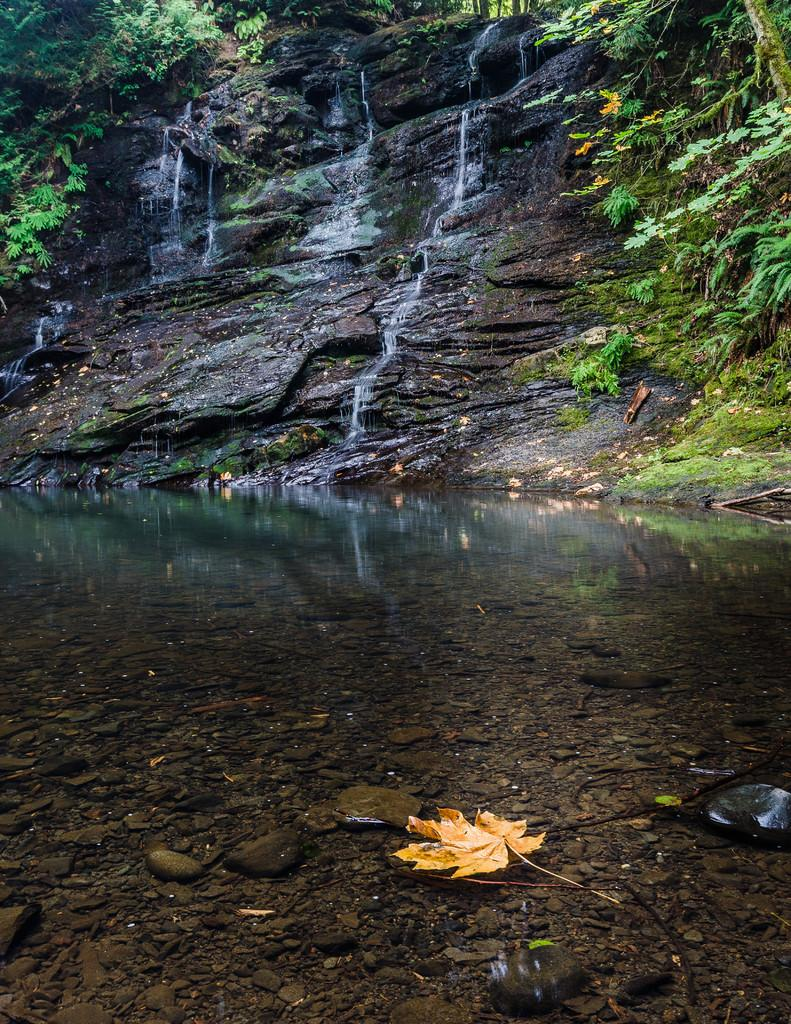What type of natural environment is depicted in the image? The image shows a forest with water. What geographical feature can be seen in the image? There is a rocky hill in the image. What is visible from the rocky hill? Waterfalls are visible from the rocky hill. What type of vegetation is near the rocky hill? There are plants near the rocky hill. What type of bells can be heard ringing in the image? There are no bells present in the image, and therefore no sound can be heard. 